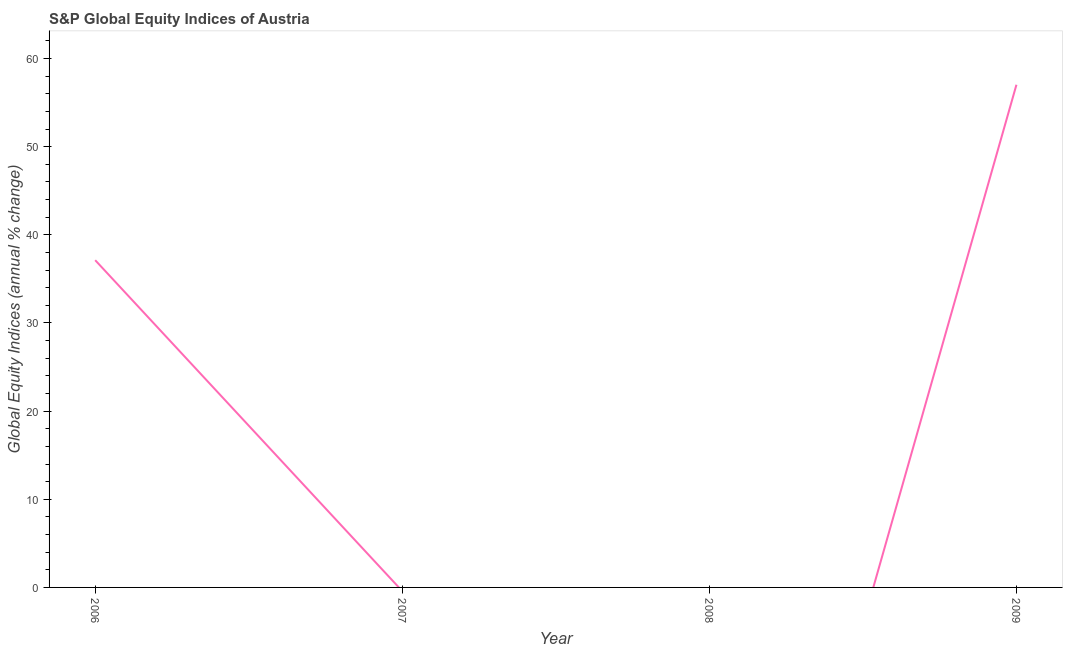What is the s&p global equity indices in 2008?
Your answer should be compact. 0. Across all years, what is the maximum s&p global equity indices?
Offer a terse response. 57.02. In which year was the s&p global equity indices maximum?
Your answer should be very brief. 2009. What is the sum of the s&p global equity indices?
Ensure brevity in your answer.  94.14. What is the average s&p global equity indices per year?
Make the answer very short. 23.54. What is the median s&p global equity indices?
Ensure brevity in your answer.  18.56. What is the ratio of the s&p global equity indices in 2006 to that in 2009?
Your response must be concise. 0.65. What is the difference between the highest and the lowest s&p global equity indices?
Ensure brevity in your answer.  57.02. What is the difference between two consecutive major ticks on the Y-axis?
Your answer should be compact. 10. Are the values on the major ticks of Y-axis written in scientific E-notation?
Ensure brevity in your answer.  No. Does the graph contain any zero values?
Offer a very short reply. Yes. What is the title of the graph?
Your answer should be very brief. S&P Global Equity Indices of Austria. What is the label or title of the Y-axis?
Provide a succinct answer. Global Equity Indices (annual % change). What is the Global Equity Indices (annual % change) of 2006?
Keep it short and to the point. 37.12. What is the Global Equity Indices (annual % change) of 2007?
Provide a succinct answer. 0. What is the Global Equity Indices (annual % change) of 2008?
Provide a short and direct response. 0. What is the Global Equity Indices (annual % change) in 2009?
Provide a short and direct response. 57.02. What is the difference between the Global Equity Indices (annual % change) in 2006 and 2009?
Give a very brief answer. -19.9. What is the ratio of the Global Equity Indices (annual % change) in 2006 to that in 2009?
Offer a very short reply. 0.65. 